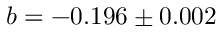Convert formula to latex. <formula><loc_0><loc_0><loc_500><loc_500>b = - 0 . 1 9 6 \pm 0 . 0 0 2</formula> 